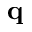Convert formula to latex. <formula><loc_0><loc_0><loc_500><loc_500>q</formula> 